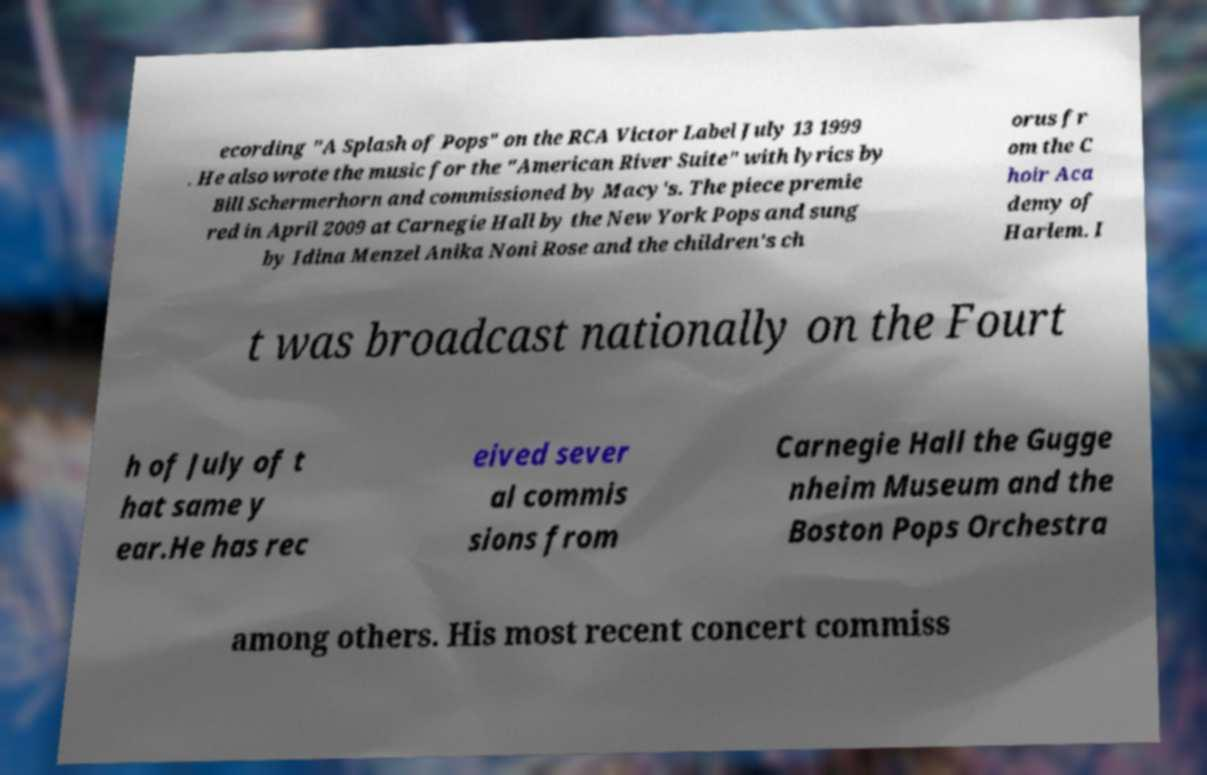Please read and relay the text visible in this image. What does it say? ecording "A Splash of Pops" on the RCA Victor Label July 13 1999 . He also wrote the music for the "American River Suite" with lyrics by Bill Schermerhorn and commissioned by Macy's. The piece premie red in April 2009 at Carnegie Hall by the New York Pops and sung by Idina Menzel Anika Noni Rose and the children's ch orus fr om the C hoir Aca demy of Harlem. I t was broadcast nationally on the Fourt h of July of t hat same y ear.He has rec eived sever al commis sions from Carnegie Hall the Gugge nheim Museum and the Boston Pops Orchestra among others. His most recent concert commiss 